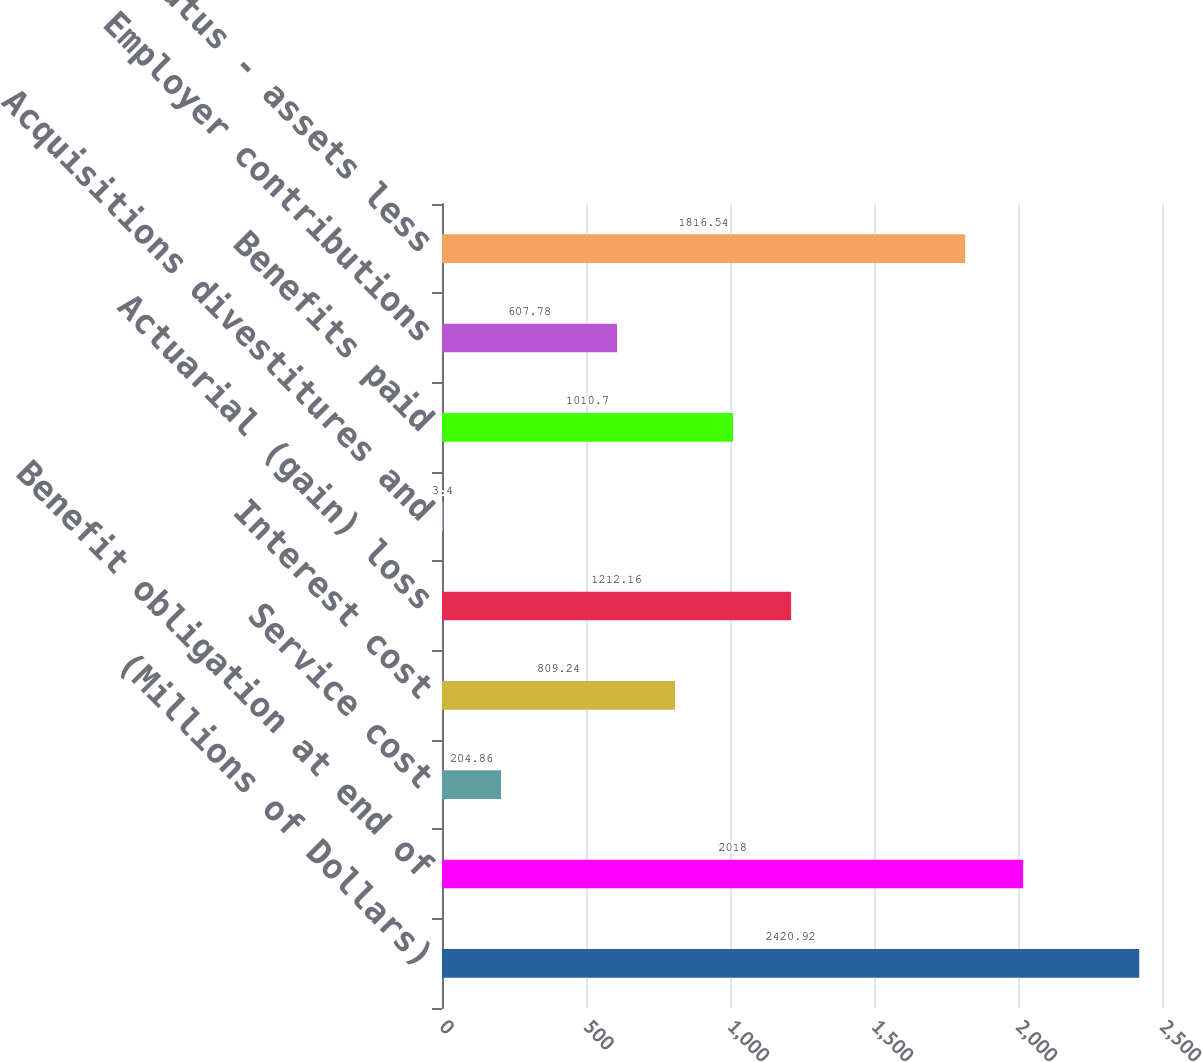Convert chart to OTSL. <chart><loc_0><loc_0><loc_500><loc_500><bar_chart><fcel>(Millions of Dollars)<fcel>Benefit obligation at end of<fcel>Service cost<fcel>Interest cost<fcel>Actuarial (gain) loss<fcel>Acquisitions divestitures and<fcel>Benefits paid<fcel>Employer contributions<fcel>Funded status - assets less<nl><fcel>2420.92<fcel>2018<fcel>204.86<fcel>809.24<fcel>1212.16<fcel>3.4<fcel>1010.7<fcel>607.78<fcel>1816.54<nl></chart> 